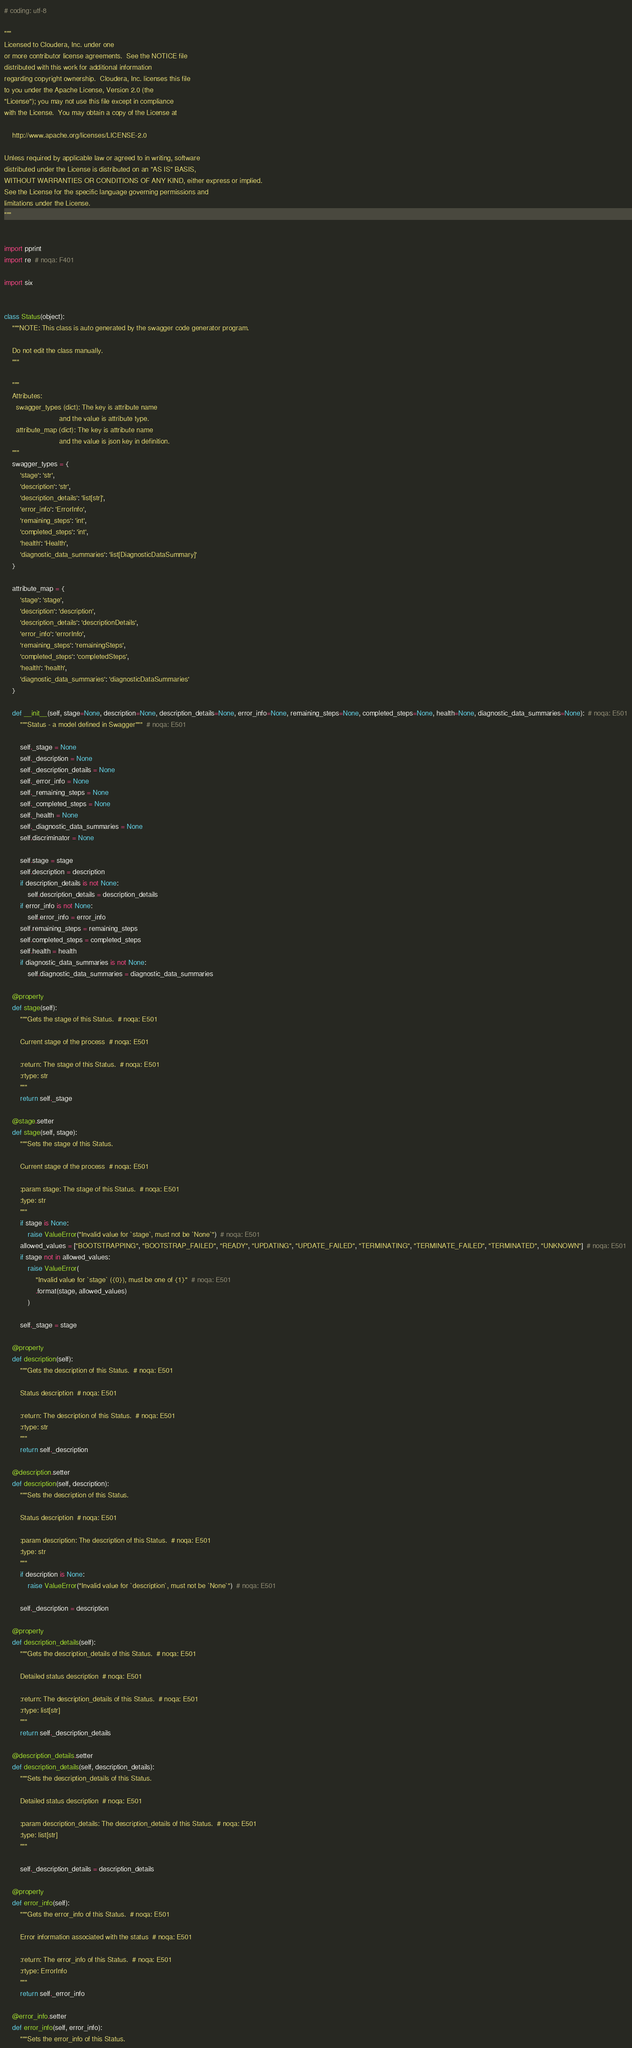<code> <loc_0><loc_0><loc_500><loc_500><_Python_># coding: utf-8

"""
Licensed to Cloudera, Inc. under one
or more contributor license agreements.  See the NOTICE file
distributed with this work for additional information
regarding copyright ownership.  Cloudera, Inc. licenses this file
to you under the Apache License, Version 2.0 (the
"License"); you may not use this file except in compliance
with the License.  You may obtain a copy of the License at

    http://www.apache.org/licenses/LICENSE-2.0

Unless required by applicable law or agreed to in writing, software
distributed under the License is distributed on an "AS IS" BASIS,
WITHOUT WARRANTIES OR CONDITIONS OF ANY KIND, either express or implied.
See the License for the specific language governing permissions and
limitations under the License.
"""


import pprint
import re  # noqa: F401

import six


class Status(object):
    """NOTE: This class is auto generated by the swagger code generator program.

    Do not edit the class manually.
    """

    """
    Attributes:
      swagger_types (dict): The key is attribute name
                            and the value is attribute type.
      attribute_map (dict): The key is attribute name
                            and the value is json key in definition.
    """
    swagger_types = {
        'stage': 'str',
        'description': 'str',
        'description_details': 'list[str]',
        'error_info': 'ErrorInfo',
        'remaining_steps': 'int',
        'completed_steps': 'int',
        'health': 'Health',
        'diagnostic_data_summaries': 'list[DiagnosticDataSummary]'
    }

    attribute_map = {
        'stage': 'stage',
        'description': 'description',
        'description_details': 'descriptionDetails',
        'error_info': 'errorInfo',
        'remaining_steps': 'remainingSteps',
        'completed_steps': 'completedSteps',
        'health': 'health',
        'diagnostic_data_summaries': 'diagnosticDataSummaries'
    }

    def __init__(self, stage=None, description=None, description_details=None, error_info=None, remaining_steps=None, completed_steps=None, health=None, diagnostic_data_summaries=None):  # noqa: E501
        """Status - a model defined in Swagger"""  # noqa: E501

        self._stage = None
        self._description = None
        self._description_details = None
        self._error_info = None
        self._remaining_steps = None
        self._completed_steps = None
        self._health = None
        self._diagnostic_data_summaries = None
        self.discriminator = None

        self.stage = stage
        self.description = description
        if description_details is not None:
            self.description_details = description_details
        if error_info is not None:
            self.error_info = error_info
        self.remaining_steps = remaining_steps
        self.completed_steps = completed_steps
        self.health = health
        if diagnostic_data_summaries is not None:
            self.diagnostic_data_summaries = diagnostic_data_summaries

    @property
    def stage(self):
        """Gets the stage of this Status.  # noqa: E501

        Current stage of the process  # noqa: E501

        :return: The stage of this Status.  # noqa: E501
        :rtype: str
        """
        return self._stage

    @stage.setter
    def stage(self, stage):
        """Sets the stage of this Status.

        Current stage of the process  # noqa: E501

        :param stage: The stage of this Status.  # noqa: E501
        :type: str
        """
        if stage is None:
            raise ValueError("Invalid value for `stage`, must not be `None`")  # noqa: E501
        allowed_values = ["BOOTSTRAPPING", "BOOTSTRAP_FAILED", "READY", "UPDATING", "UPDATE_FAILED", "TERMINATING", "TERMINATE_FAILED", "TERMINATED", "UNKNOWN"]  # noqa: E501
        if stage not in allowed_values:
            raise ValueError(
                "Invalid value for `stage` ({0}), must be one of {1}"  # noqa: E501
                .format(stage, allowed_values)
            )

        self._stage = stage

    @property
    def description(self):
        """Gets the description of this Status.  # noqa: E501

        Status description  # noqa: E501

        :return: The description of this Status.  # noqa: E501
        :rtype: str
        """
        return self._description

    @description.setter
    def description(self, description):
        """Sets the description of this Status.

        Status description  # noqa: E501

        :param description: The description of this Status.  # noqa: E501
        :type: str
        """
        if description is None:
            raise ValueError("Invalid value for `description`, must not be `None`")  # noqa: E501

        self._description = description

    @property
    def description_details(self):
        """Gets the description_details of this Status.  # noqa: E501

        Detailed status description  # noqa: E501

        :return: The description_details of this Status.  # noqa: E501
        :rtype: list[str]
        """
        return self._description_details

    @description_details.setter
    def description_details(self, description_details):
        """Sets the description_details of this Status.

        Detailed status description  # noqa: E501

        :param description_details: The description_details of this Status.  # noqa: E501
        :type: list[str]
        """

        self._description_details = description_details

    @property
    def error_info(self):
        """Gets the error_info of this Status.  # noqa: E501

        Error information associated with the status  # noqa: E501

        :return: The error_info of this Status.  # noqa: E501
        :rtype: ErrorInfo
        """
        return self._error_info

    @error_info.setter
    def error_info(self, error_info):
        """Sets the error_info of this Status.
</code> 